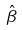Convert formula to latex. <formula><loc_0><loc_0><loc_500><loc_500>\hat { \beta }</formula> 